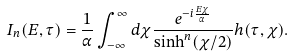<formula> <loc_0><loc_0><loc_500><loc_500>I _ { n } ( E , \tau ) = \frac { 1 } { \alpha } \int _ { - \infty } ^ { \infty } d \chi \frac { e ^ { - i \frac { E \chi } { \alpha } } } { \sinh ^ { n } ( \chi / 2 ) } h ( \tau , \chi ) .</formula> 